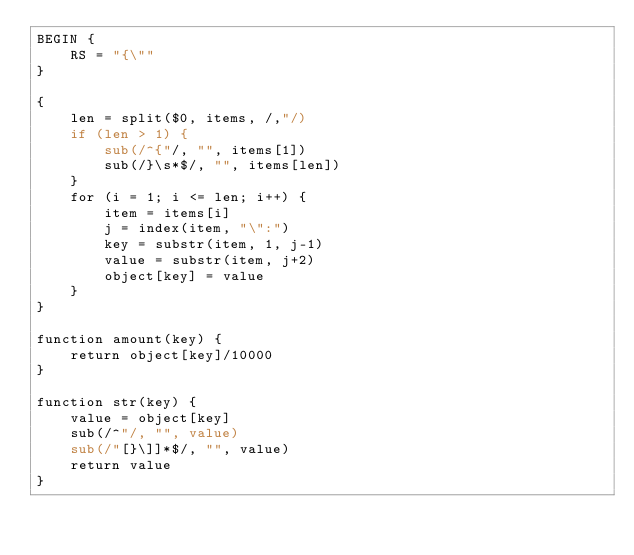<code> <loc_0><loc_0><loc_500><loc_500><_Awk_>BEGIN {
	RS = "{\""
}

{
	len = split($0, items, /,"/)
	if (len > 1) {
		sub(/^{"/, "", items[1])
		sub(/}\s*$/, "", items[len])
	}
	for (i = 1; i <= len; i++) {
		item = items[i]
		j = index(item, "\":")
		key = substr(item, 1, j-1)
		value = substr(item, j+2)
		object[key] = value
	}
}

function amount(key) {
	return object[key]/10000
}

function str(key) {
	value = object[key]
	sub(/^"/, "", value)
	sub(/"[}\]]*$/, "", value)
	return value
}
</code> 